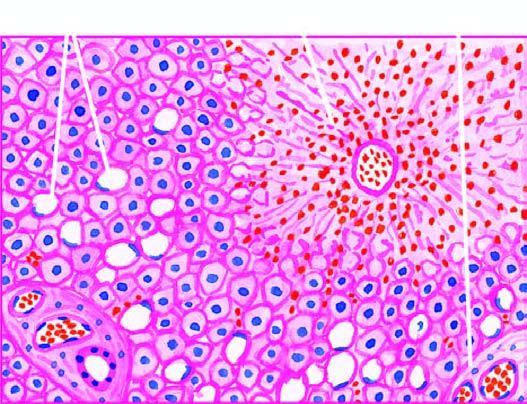what does the centrilobular zone show?
Answer the question using a single word or phrase. Marked degeneration and necrosis of hepatocytes accompanied by haemorrhage 